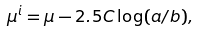Convert formula to latex. <formula><loc_0><loc_0><loc_500><loc_500>\mu ^ { i } = \mu - 2 . 5 C \log ( a / b ) ,</formula> 